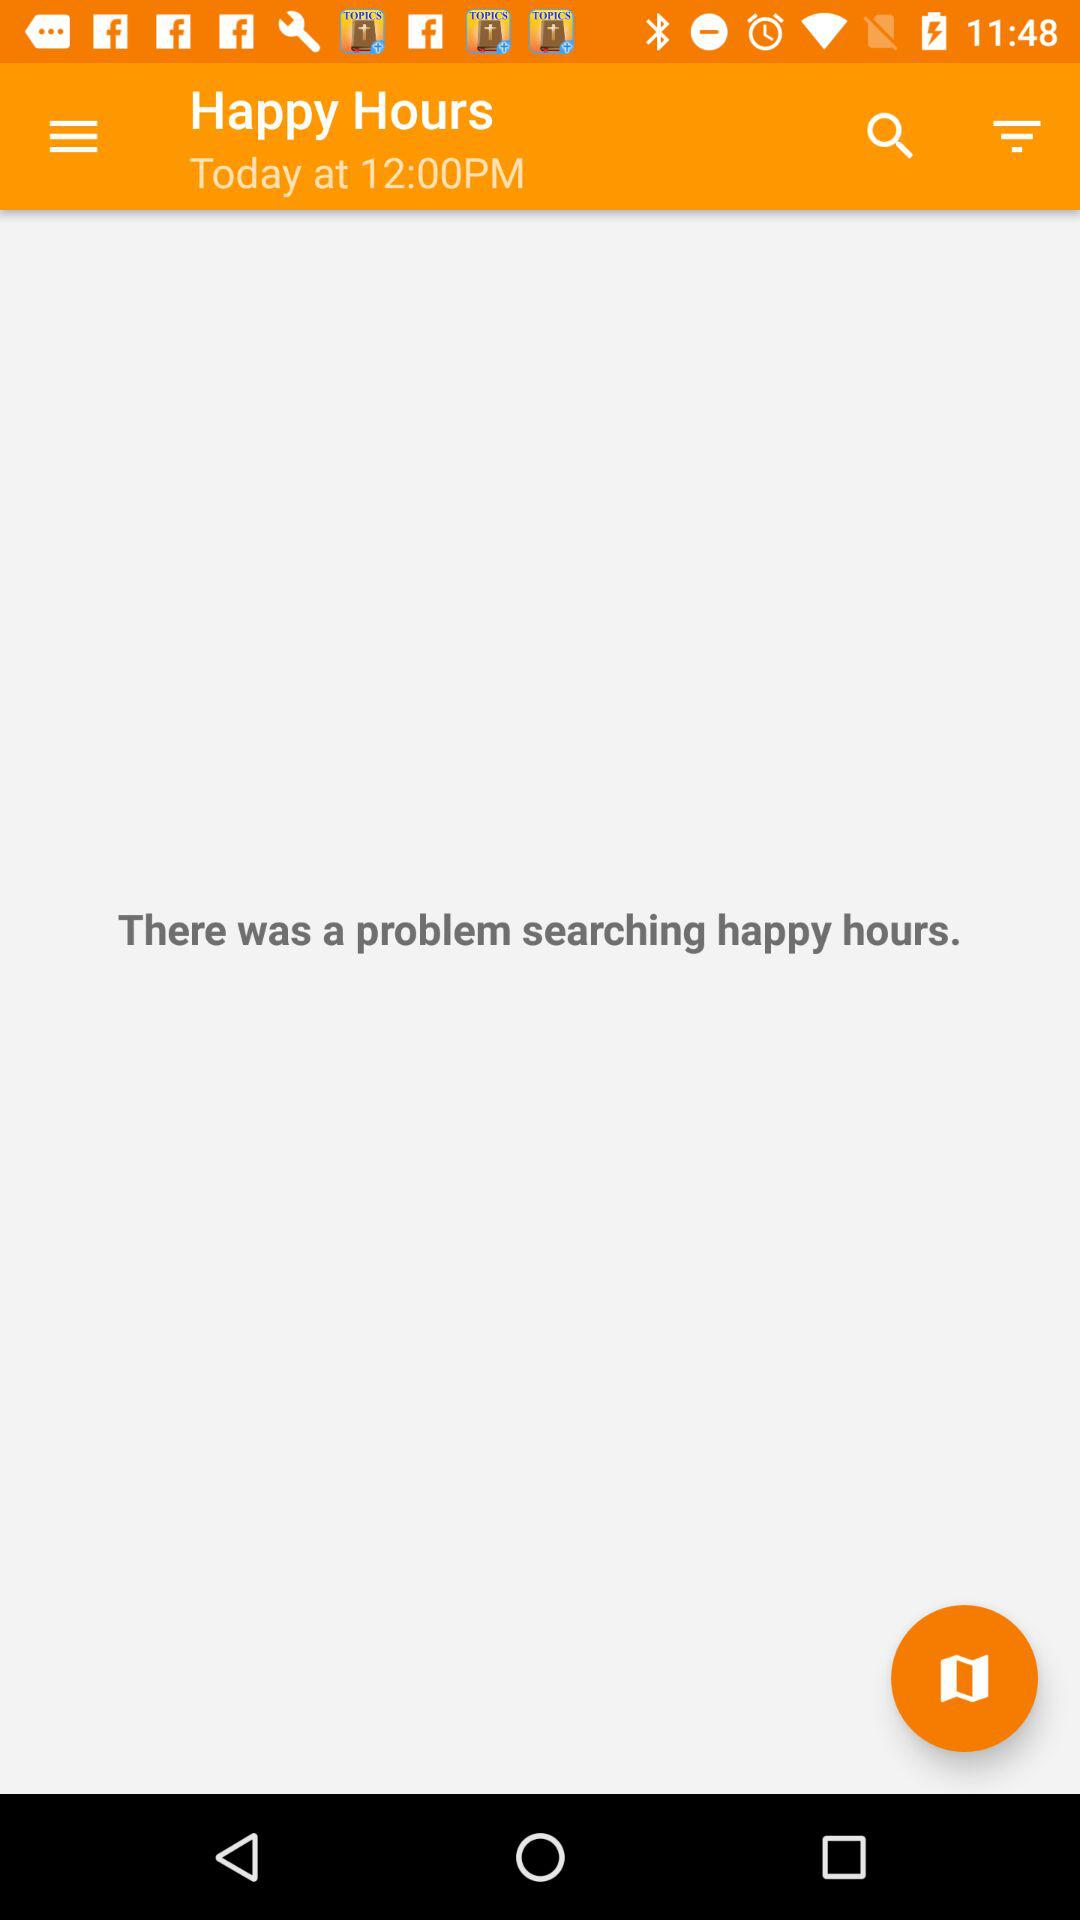Where is "Happy Hours" located?
When the provided information is insufficient, respond with <no answer>. <no answer> 